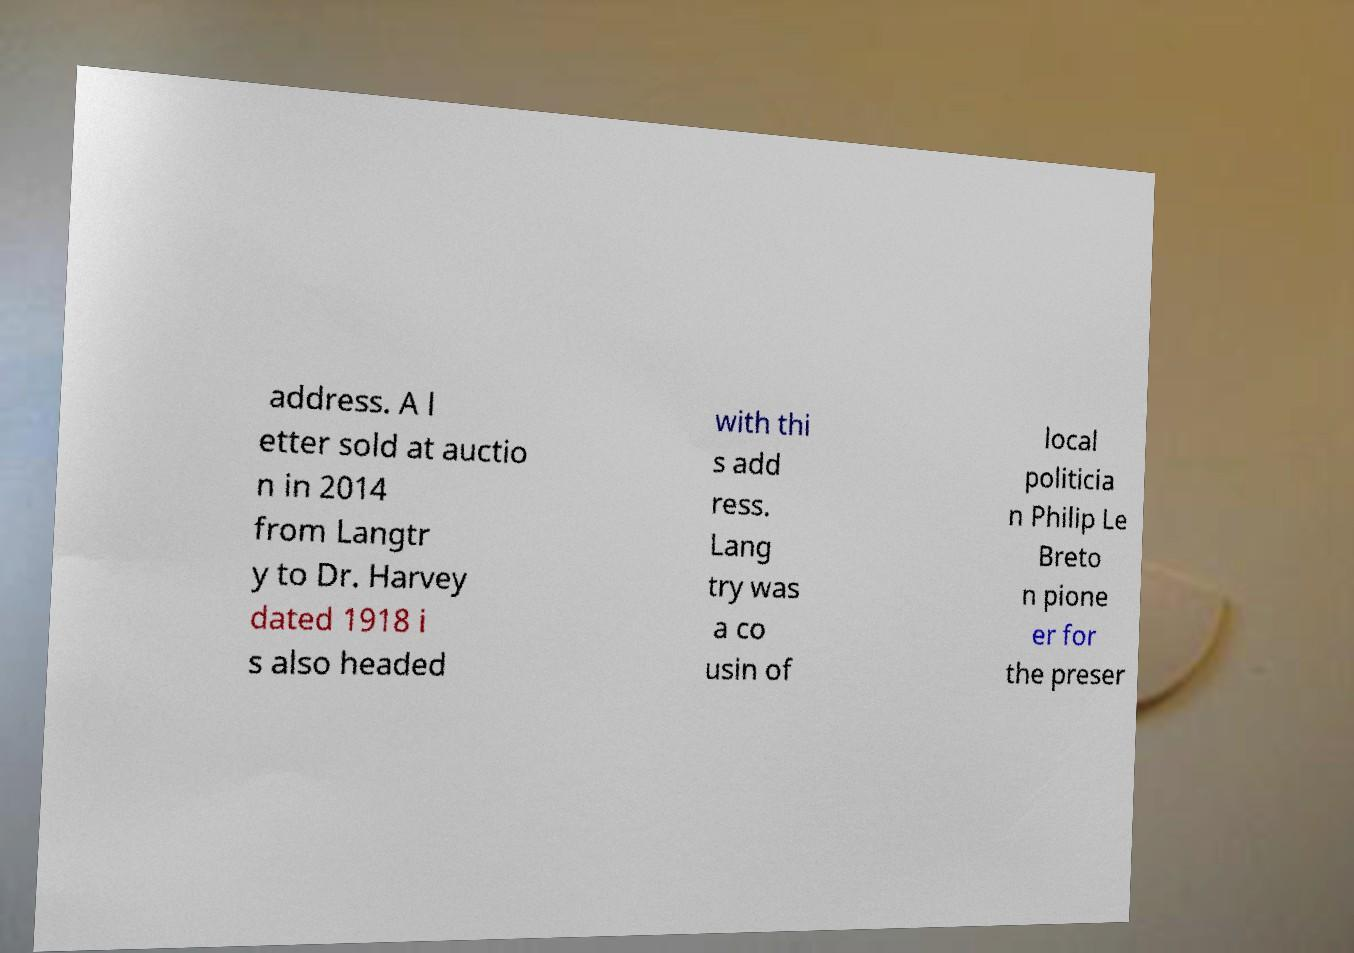Could you assist in decoding the text presented in this image and type it out clearly? address. A l etter sold at auctio n in 2014 from Langtr y to Dr. Harvey dated 1918 i s also headed with thi s add ress. Lang try was a co usin of local politicia n Philip Le Breto n pione er for the preser 